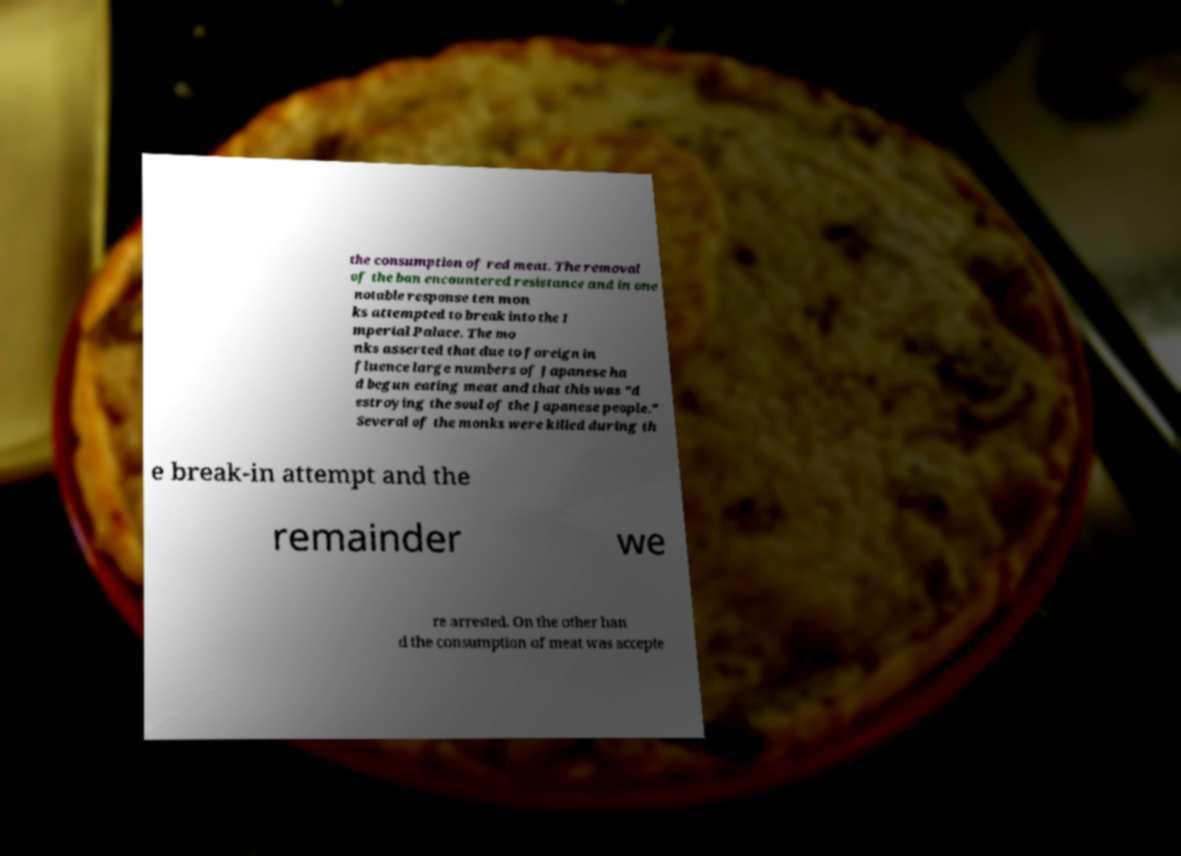I need the written content from this picture converted into text. Can you do that? the consumption of red meat. The removal of the ban encountered resistance and in one notable response ten mon ks attempted to break into the I mperial Palace. The mo nks asserted that due to foreign in fluence large numbers of Japanese ha d begun eating meat and that this was "d estroying the soul of the Japanese people." Several of the monks were killed during th e break-in attempt and the remainder we re arrested. On the other han d the consumption of meat was accepte 